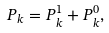Convert formula to latex. <formula><loc_0><loc_0><loc_500><loc_500>P _ { k } = P _ { k } ^ { 1 } + P _ { k } ^ { 0 } ,</formula> 